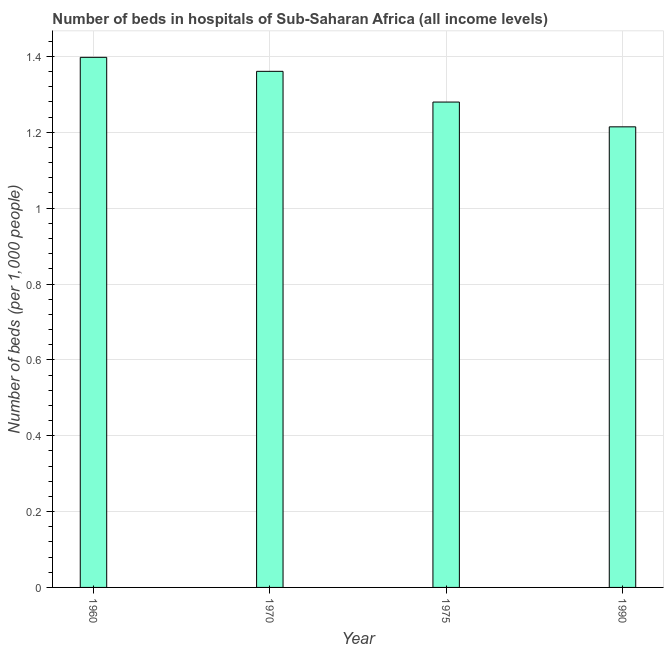Does the graph contain any zero values?
Provide a succinct answer. No. What is the title of the graph?
Your response must be concise. Number of beds in hospitals of Sub-Saharan Africa (all income levels). What is the label or title of the X-axis?
Keep it short and to the point. Year. What is the label or title of the Y-axis?
Keep it short and to the point. Number of beds (per 1,0 people). What is the number of hospital beds in 1960?
Keep it short and to the point. 1.4. Across all years, what is the maximum number of hospital beds?
Offer a very short reply. 1.4. Across all years, what is the minimum number of hospital beds?
Your answer should be compact. 1.21. In which year was the number of hospital beds minimum?
Provide a short and direct response. 1990. What is the sum of the number of hospital beds?
Offer a very short reply. 5.25. What is the difference between the number of hospital beds in 1975 and 1990?
Give a very brief answer. 0.07. What is the average number of hospital beds per year?
Your answer should be compact. 1.31. What is the median number of hospital beds?
Provide a short and direct response. 1.32. What is the ratio of the number of hospital beds in 1975 to that in 1990?
Keep it short and to the point. 1.05. What is the difference between the highest and the second highest number of hospital beds?
Offer a terse response. 0.04. Is the sum of the number of hospital beds in 1975 and 1990 greater than the maximum number of hospital beds across all years?
Your answer should be very brief. Yes. What is the difference between the highest and the lowest number of hospital beds?
Give a very brief answer. 0.18. How many bars are there?
Your response must be concise. 4. Are all the bars in the graph horizontal?
Provide a succinct answer. No. How many years are there in the graph?
Offer a terse response. 4. Are the values on the major ticks of Y-axis written in scientific E-notation?
Your response must be concise. No. What is the Number of beds (per 1,000 people) of 1960?
Provide a succinct answer. 1.4. What is the Number of beds (per 1,000 people) of 1970?
Your response must be concise. 1.36. What is the Number of beds (per 1,000 people) in 1975?
Your response must be concise. 1.28. What is the Number of beds (per 1,000 people) in 1990?
Your response must be concise. 1.21. What is the difference between the Number of beds (per 1,000 people) in 1960 and 1970?
Provide a succinct answer. 0.04. What is the difference between the Number of beds (per 1,000 people) in 1960 and 1975?
Keep it short and to the point. 0.12. What is the difference between the Number of beds (per 1,000 people) in 1960 and 1990?
Give a very brief answer. 0.18. What is the difference between the Number of beds (per 1,000 people) in 1970 and 1975?
Ensure brevity in your answer.  0.08. What is the difference between the Number of beds (per 1,000 people) in 1970 and 1990?
Give a very brief answer. 0.15. What is the difference between the Number of beds (per 1,000 people) in 1975 and 1990?
Keep it short and to the point. 0.07. What is the ratio of the Number of beds (per 1,000 people) in 1960 to that in 1970?
Keep it short and to the point. 1.03. What is the ratio of the Number of beds (per 1,000 people) in 1960 to that in 1975?
Provide a succinct answer. 1.09. What is the ratio of the Number of beds (per 1,000 people) in 1960 to that in 1990?
Your answer should be very brief. 1.15. What is the ratio of the Number of beds (per 1,000 people) in 1970 to that in 1975?
Offer a terse response. 1.06. What is the ratio of the Number of beds (per 1,000 people) in 1970 to that in 1990?
Ensure brevity in your answer.  1.12. What is the ratio of the Number of beds (per 1,000 people) in 1975 to that in 1990?
Your answer should be compact. 1.05. 